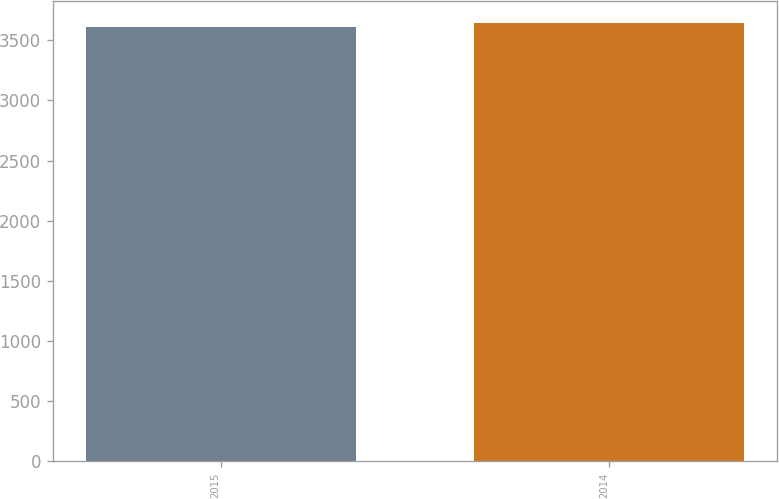Convert chart to OTSL. <chart><loc_0><loc_0><loc_500><loc_500><bar_chart><fcel>2015<fcel>2014<nl><fcel>3611<fcel>3644<nl></chart> 